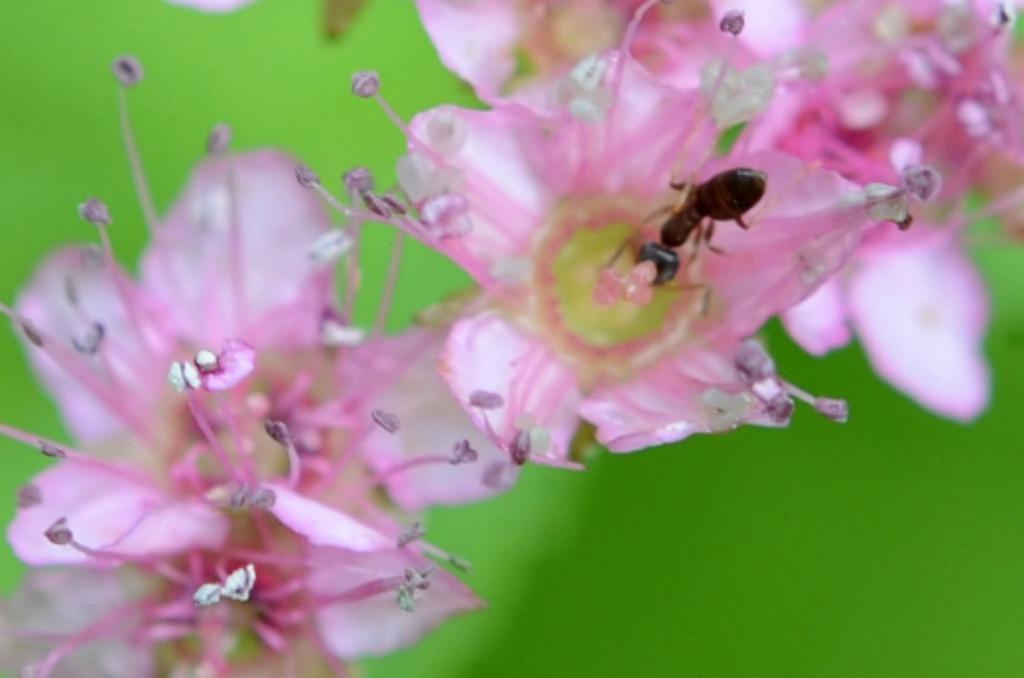How would you summarize this image in a sentence or two? In this picture we can see the pink flower with black ant is sitting on the flower. Behind there is a green blur background. 